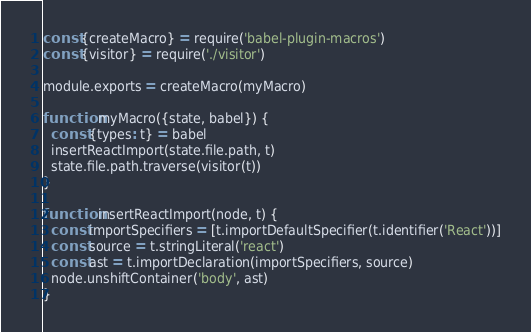Convert code to text. <code><loc_0><loc_0><loc_500><loc_500><_JavaScript_>const {createMacro} = require('babel-plugin-macros')
const {visitor} = require('./visitor')

module.exports = createMacro(myMacro)

function myMacro({state, babel}) {
  const {types: t} = babel
  insertReactImport(state.file.path, t)
  state.file.path.traverse(visitor(t))
}

function insertReactImport(node, t) {
  const importSpecifiers = [t.importDefaultSpecifier(t.identifier('React'))]
  const source = t.stringLiteral('react')
  const ast = t.importDeclaration(importSpecifiers, source)
  node.unshiftContainer('body', ast)
}
</code> 